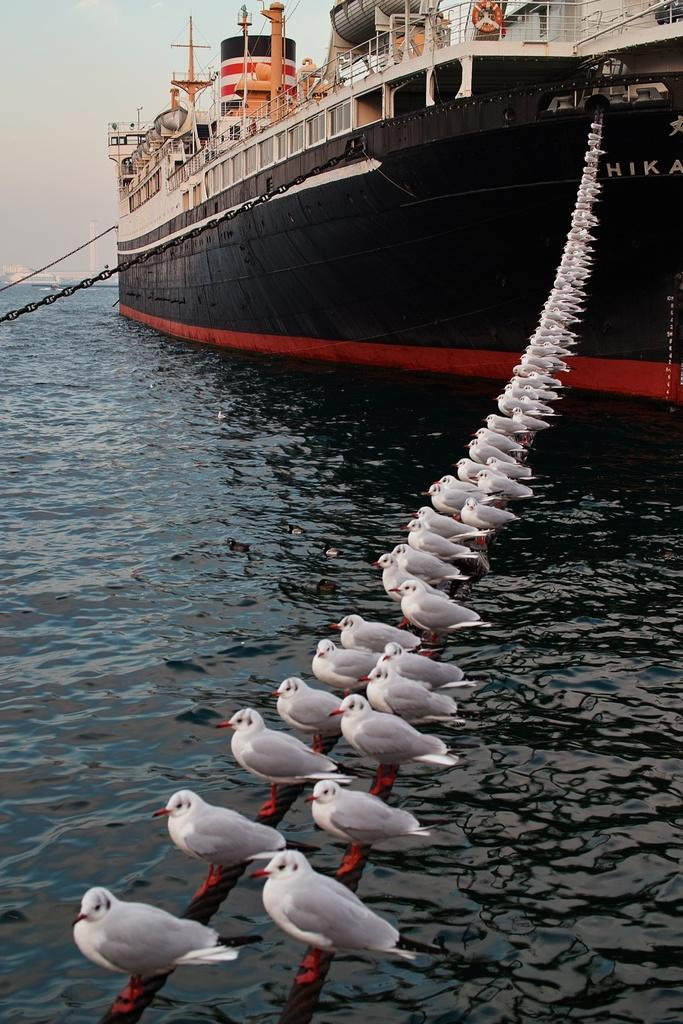What is the main subject of the image? There is a ship sailing on the water in the image. What other living creatures can be seen in the image? There are birds visible in the image. Where are the birds located in relation to the ship? The birds are on some objects in the image. What part of the natural environment is visible in the image? The sky is visible in the image. What type of songs are the birds singing in the image? There is no indication in the image that the birds are singing songs, so it cannot be determined from the picture. 